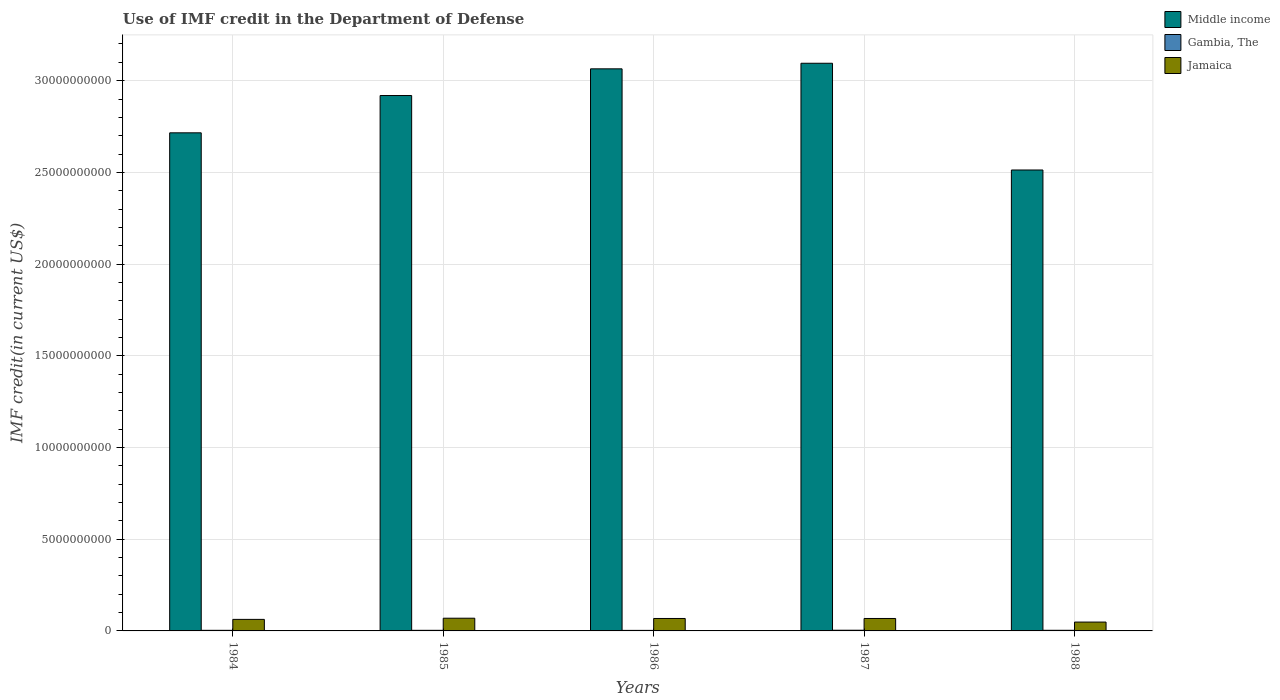How many different coloured bars are there?
Offer a very short reply. 3. How many groups of bars are there?
Provide a succinct answer. 5. How many bars are there on the 4th tick from the right?
Make the answer very short. 3. What is the label of the 4th group of bars from the left?
Provide a short and direct response. 1987. In how many cases, is the number of bars for a given year not equal to the number of legend labels?
Your answer should be very brief. 0. What is the IMF credit in the Department of Defense in Jamaica in 1984?
Your answer should be very brief. 6.29e+08. Across all years, what is the maximum IMF credit in the Department of Defense in Jamaica?
Your answer should be very brief. 6.93e+08. Across all years, what is the minimum IMF credit in the Department of Defense in Jamaica?
Your response must be concise. 4.83e+08. In which year was the IMF credit in the Department of Defense in Gambia, The maximum?
Offer a terse response. 1987. In which year was the IMF credit in the Department of Defense in Middle income minimum?
Give a very brief answer. 1988. What is the total IMF credit in the Department of Defense in Gambia, The in the graph?
Offer a very short reply. 1.68e+08. What is the difference between the IMF credit in the Department of Defense in Gambia, The in 1985 and that in 1986?
Give a very brief answer. 3.45e+06. What is the difference between the IMF credit in the Department of Defense in Gambia, The in 1988 and the IMF credit in the Department of Defense in Middle income in 1987?
Give a very brief answer. -3.09e+1. What is the average IMF credit in the Department of Defense in Jamaica per year?
Provide a succinct answer. 6.32e+08. In the year 1987, what is the difference between the IMF credit in the Department of Defense in Middle income and IMF credit in the Department of Defense in Jamaica?
Keep it short and to the point. 3.03e+1. What is the ratio of the IMF credit in the Department of Defense in Jamaica in 1985 to that in 1988?
Give a very brief answer. 1.44. What is the difference between the highest and the second highest IMF credit in the Department of Defense in Gambia, The?
Provide a succinct answer. 3.23e+06. What is the difference between the highest and the lowest IMF credit in the Department of Defense in Gambia, The?
Provide a succinct answer. 8.27e+06. What does the 1st bar from the left in 1987 represents?
Your answer should be compact. Middle income. What does the 1st bar from the right in 1987 represents?
Provide a succinct answer. Jamaica. Is it the case that in every year, the sum of the IMF credit in the Department of Defense in Gambia, The and IMF credit in the Department of Defense in Jamaica is greater than the IMF credit in the Department of Defense in Middle income?
Keep it short and to the point. No. Are all the bars in the graph horizontal?
Provide a succinct answer. No. How many years are there in the graph?
Provide a short and direct response. 5. Does the graph contain any zero values?
Your response must be concise. No. Where does the legend appear in the graph?
Provide a succinct answer. Top right. How are the legend labels stacked?
Your answer should be very brief. Vertical. What is the title of the graph?
Make the answer very short. Use of IMF credit in the Department of Defense. Does "Burkina Faso" appear as one of the legend labels in the graph?
Your answer should be compact. No. What is the label or title of the X-axis?
Ensure brevity in your answer.  Years. What is the label or title of the Y-axis?
Your answer should be compact. IMF credit(in current US$). What is the IMF credit(in current US$) in Middle income in 1984?
Keep it short and to the point. 2.72e+1. What is the IMF credit(in current US$) of Gambia, The in 1984?
Offer a terse response. 3.29e+07. What is the IMF credit(in current US$) of Jamaica in 1984?
Ensure brevity in your answer.  6.29e+08. What is the IMF credit(in current US$) of Middle income in 1985?
Offer a terse response. 2.92e+1. What is the IMF credit(in current US$) in Gambia, The in 1985?
Your answer should be very brief. 3.30e+07. What is the IMF credit(in current US$) of Jamaica in 1985?
Your response must be concise. 6.93e+08. What is the IMF credit(in current US$) in Middle income in 1986?
Provide a succinct answer. 3.06e+1. What is the IMF credit(in current US$) in Gambia, The in 1986?
Keep it short and to the point. 2.95e+07. What is the IMF credit(in current US$) in Jamaica in 1986?
Offer a terse response. 6.78e+08. What is the IMF credit(in current US$) in Middle income in 1987?
Your answer should be very brief. 3.09e+1. What is the IMF credit(in current US$) in Gambia, The in 1987?
Your answer should be compact. 3.78e+07. What is the IMF credit(in current US$) in Jamaica in 1987?
Offer a very short reply. 6.78e+08. What is the IMF credit(in current US$) of Middle income in 1988?
Ensure brevity in your answer.  2.51e+1. What is the IMF credit(in current US$) of Gambia, The in 1988?
Your answer should be compact. 3.46e+07. What is the IMF credit(in current US$) of Jamaica in 1988?
Ensure brevity in your answer.  4.83e+08. Across all years, what is the maximum IMF credit(in current US$) in Middle income?
Ensure brevity in your answer.  3.09e+1. Across all years, what is the maximum IMF credit(in current US$) in Gambia, The?
Give a very brief answer. 3.78e+07. Across all years, what is the maximum IMF credit(in current US$) of Jamaica?
Ensure brevity in your answer.  6.93e+08. Across all years, what is the minimum IMF credit(in current US$) of Middle income?
Ensure brevity in your answer.  2.51e+1. Across all years, what is the minimum IMF credit(in current US$) in Gambia, The?
Your answer should be very brief. 2.95e+07. Across all years, what is the minimum IMF credit(in current US$) of Jamaica?
Make the answer very short. 4.83e+08. What is the total IMF credit(in current US$) in Middle income in the graph?
Your answer should be very brief. 1.43e+11. What is the total IMF credit(in current US$) of Gambia, The in the graph?
Provide a short and direct response. 1.68e+08. What is the total IMF credit(in current US$) of Jamaica in the graph?
Your answer should be very brief. 3.16e+09. What is the difference between the IMF credit(in current US$) of Middle income in 1984 and that in 1985?
Your response must be concise. -2.03e+09. What is the difference between the IMF credit(in current US$) in Gambia, The in 1984 and that in 1985?
Make the answer very short. -3.20e+04. What is the difference between the IMF credit(in current US$) of Jamaica in 1984 and that in 1985?
Keep it short and to the point. -6.45e+07. What is the difference between the IMF credit(in current US$) in Middle income in 1984 and that in 1986?
Ensure brevity in your answer.  -3.49e+09. What is the difference between the IMF credit(in current US$) in Gambia, The in 1984 and that in 1986?
Make the answer very short. 3.42e+06. What is the difference between the IMF credit(in current US$) of Jamaica in 1984 and that in 1986?
Give a very brief answer. -4.94e+07. What is the difference between the IMF credit(in current US$) of Middle income in 1984 and that in 1987?
Make the answer very short. -3.79e+09. What is the difference between the IMF credit(in current US$) of Gambia, The in 1984 and that in 1987?
Provide a short and direct response. -4.86e+06. What is the difference between the IMF credit(in current US$) in Jamaica in 1984 and that in 1987?
Offer a terse response. -4.97e+07. What is the difference between the IMF credit(in current US$) of Middle income in 1984 and that in 1988?
Give a very brief answer. 2.03e+09. What is the difference between the IMF credit(in current US$) in Gambia, The in 1984 and that in 1988?
Make the answer very short. -1.63e+06. What is the difference between the IMF credit(in current US$) in Jamaica in 1984 and that in 1988?
Your answer should be compact. 1.46e+08. What is the difference between the IMF credit(in current US$) of Middle income in 1985 and that in 1986?
Give a very brief answer. -1.46e+09. What is the difference between the IMF credit(in current US$) of Gambia, The in 1985 and that in 1986?
Your answer should be very brief. 3.45e+06. What is the difference between the IMF credit(in current US$) of Jamaica in 1985 and that in 1986?
Your answer should be compact. 1.50e+07. What is the difference between the IMF credit(in current US$) in Middle income in 1985 and that in 1987?
Your answer should be compact. -1.76e+09. What is the difference between the IMF credit(in current US$) in Gambia, The in 1985 and that in 1987?
Your response must be concise. -4.83e+06. What is the difference between the IMF credit(in current US$) in Jamaica in 1985 and that in 1987?
Your answer should be compact. 1.48e+07. What is the difference between the IMF credit(in current US$) of Middle income in 1985 and that in 1988?
Your answer should be compact. 4.06e+09. What is the difference between the IMF credit(in current US$) in Gambia, The in 1985 and that in 1988?
Your response must be concise. -1.60e+06. What is the difference between the IMF credit(in current US$) in Jamaica in 1985 and that in 1988?
Make the answer very short. 2.10e+08. What is the difference between the IMF credit(in current US$) in Middle income in 1986 and that in 1987?
Your response must be concise. -3.04e+08. What is the difference between the IMF credit(in current US$) of Gambia, The in 1986 and that in 1987?
Provide a short and direct response. -8.27e+06. What is the difference between the IMF credit(in current US$) in Jamaica in 1986 and that in 1987?
Offer a very short reply. -2.93e+05. What is the difference between the IMF credit(in current US$) of Middle income in 1986 and that in 1988?
Make the answer very short. 5.52e+09. What is the difference between the IMF credit(in current US$) of Gambia, The in 1986 and that in 1988?
Your answer should be compact. -5.04e+06. What is the difference between the IMF credit(in current US$) in Jamaica in 1986 and that in 1988?
Your answer should be compact. 1.95e+08. What is the difference between the IMF credit(in current US$) in Middle income in 1987 and that in 1988?
Keep it short and to the point. 5.82e+09. What is the difference between the IMF credit(in current US$) of Gambia, The in 1987 and that in 1988?
Keep it short and to the point. 3.23e+06. What is the difference between the IMF credit(in current US$) of Jamaica in 1987 and that in 1988?
Provide a short and direct response. 1.96e+08. What is the difference between the IMF credit(in current US$) in Middle income in 1984 and the IMF credit(in current US$) in Gambia, The in 1985?
Your answer should be very brief. 2.71e+1. What is the difference between the IMF credit(in current US$) in Middle income in 1984 and the IMF credit(in current US$) in Jamaica in 1985?
Your response must be concise. 2.65e+1. What is the difference between the IMF credit(in current US$) of Gambia, The in 1984 and the IMF credit(in current US$) of Jamaica in 1985?
Provide a succinct answer. -6.60e+08. What is the difference between the IMF credit(in current US$) of Middle income in 1984 and the IMF credit(in current US$) of Gambia, The in 1986?
Your response must be concise. 2.71e+1. What is the difference between the IMF credit(in current US$) in Middle income in 1984 and the IMF credit(in current US$) in Jamaica in 1986?
Your response must be concise. 2.65e+1. What is the difference between the IMF credit(in current US$) of Gambia, The in 1984 and the IMF credit(in current US$) of Jamaica in 1986?
Ensure brevity in your answer.  -6.45e+08. What is the difference between the IMF credit(in current US$) in Middle income in 1984 and the IMF credit(in current US$) in Gambia, The in 1987?
Your answer should be compact. 2.71e+1. What is the difference between the IMF credit(in current US$) of Middle income in 1984 and the IMF credit(in current US$) of Jamaica in 1987?
Give a very brief answer. 2.65e+1. What is the difference between the IMF credit(in current US$) of Gambia, The in 1984 and the IMF credit(in current US$) of Jamaica in 1987?
Make the answer very short. -6.46e+08. What is the difference between the IMF credit(in current US$) of Middle income in 1984 and the IMF credit(in current US$) of Gambia, The in 1988?
Make the answer very short. 2.71e+1. What is the difference between the IMF credit(in current US$) in Middle income in 1984 and the IMF credit(in current US$) in Jamaica in 1988?
Offer a terse response. 2.67e+1. What is the difference between the IMF credit(in current US$) of Gambia, The in 1984 and the IMF credit(in current US$) of Jamaica in 1988?
Offer a terse response. -4.50e+08. What is the difference between the IMF credit(in current US$) in Middle income in 1985 and the IMF credit(in current US$) in Gambia, The in 1986?
Give a very brief answer. 2.92e+1. What is the difference between the IMF credit(in current US$) in Middle income in 1985 and the IMF credit(in current US$) in Jamaica in 1986?
Offer a terse response. 2.85e+1. What is the difference between the IMF credit(in current US$) of Gambia, The in 1985 and the IMF credit(in current US$) of Jamaica in 1986?
Provide a succinct answer. -6.45e+08. What is the difference between the IMF credit(in current US$) in Middle income in 1985 and the IMF credit(in current US$) in Gambia, The in 1987?
Keep it short and to the point. 2.92e+1. What is the difference between the IMF credit(in current US$) in Middle income in 1985 and the IMF credit(in current US$) in Jamaica in 1987?
Provide a short and direct response. 2.85e+1. What is the difference between the IMF credit(in current US$) of Gambia, The in 1985 and the IMF credit(in current US$) of Jamaica in 1987?
Make the answer very short. -6.45e+08. What is the difference between the IMF credit(in current US$) of Middle income in 1985 and the IMF credit(in current US$) of Gambia, The in 1988?
Provide a succinct answer. 2.92e+1. What is the difference between the IMF credit(in current US$) of Middle income in 1985 and the IMF credit(in current US$) of Jamaica in 1988?
Keep it short and to the point. 2.87e+1. What is the difference between the IMF credit(in current US$) of Gambia, The in 1985 and the IMF credit(in current US$) of Jamaica in 1988?
Provide a short and direct response. -4.50e+08. What is the difference between the IMF credit(in current US$) in Middle income in 1986 and the IMF credit(in current US$) in Gambia, The in 1987?
Offer a terse response. 3.06e+1. What is the difference between the IMF credit(in current US$) of Middle income in 1986 and the IMF credit(in current US$) of Jamaica in 1987?
Your answer should be compact. 3.00e+1. What is the difference between the IMF credit(in current US$) of Gambia, The in 1986 and the IMF credit(in current US$) of Jamaica in 1987?
Your answer should be very brief. -6.49e+08. What is the difference between the IMF credit(in current US$) in Middle income in 1986 and the IMF credit(in current US$) in Gambia, The in 1988?
Your answer should be very brief. 3.06e+1. What is the difference between the IMF credit(in current US$) of Middle income in 1986 and the IMF credit(in current US$) of Jamaica in 1988?
Ensure brevity in your answer.  3.02e+1. What is the difference between the IMF credit(in current US$) in Gambia, The in 1986 and the IMF credit(in current US$) in Jamaica in 1988?
Ensure brevity in your answer.  -4.53e+08. What is the difference between the IMF credit(in current US$) of Middle income in 1987 and the IMF credit(in current US$) of Gambia, The in 1988?
Keep it short and to the point. 3.09e+1. What is the difference between the IMF credit(in current US$) in Middle income in 1987 and the IMF credit(in current US$) in Jamaica in 1988?
Ensure brevity in your answer.  3.05e+1. What is the difference between the IMF credit(in current US$) of Gambia, The in 1987 and the IMF credit(in current US$) of Jamaica in 1988?
Offer a very short reply. -4.45e+08. What is the average IMF credit(in current US$) of Middle income per year?
Your answer should be very brief. 2.86e+1. What is the average IMF credit(in current US$) in Gambia, The per year?
Offer a very short reply. 3.36e+07. What is the average IMF credit(in current US$) in Jamaica per year?
Your answer should be compact. 6.32e+08. In the year 1984, what is the difference between the IMF credit(in current US$) of Middle income and IMF credit(in current US$) of Gambia, The?
Your response must be concise. 2.71e+1. In the year 1984, what is the difference between the IMF credit(in current US$) of Middle income and IMF credit(in current US$) of Jamaica?
Offer a terse response. 2.65e+1. In the year 1984, what is the difference between the IMF credit(in current US$) of Gambia, The and IMF credit(in current US$) of Jamaica?
Keep it short and to the point. -5.96e+08. In the year 1985, what is the difference between the IMF credit(in current US$) in Middle income and IMF credit(in current US$) in Gambia, The?
Provide a succinct answer. 2.92e+1. In the year 1985, what is the difference between the IMF credit(in current US$) in Middle income and IMF credit(in current US$) in Jamaica?
Provide a succinct answer. 2.85e+1. In the year 1985, what is the difference between the IMF credit(in current US$) in Gambia, The and IMF credit(in current US$) in Jamaica?
Keep it short and to the point. -6.60e+08. In the year 1986, what is the difference between the IMF credit(in current US$) in Middle income and IMF credit(in current US$) in Gambia, The?
Make the answer very short. 3.06e+1. In the year 1986, what is the difference between the IMF credit(in current US$) in Middle income and IMF credit(in current US$) in Jamaica?
Offer a very short reply. 3.00e+1. In the year 1986, what is the difference between the IMF credit(in current US$) in Gambia, The and IMF credit(in current US$) in Jamaica?
Your answer should be very brief. -6.49e+08. In the year 1987, what is the difference between the IMF credit(in current US$) of Middle income and IMF credit(in current US$) of Gambia, The?
Your answer should be very brief. 3.09e+1. In the year 1987, what is the difference between the IMF credit(in current US$) in Middle income and IMF credit(in current US$) in Jamaica?
Keep it short and to the point. 3.03e+1. In the year 1987, what is the difference between the IMF credit(in current US$) in Gambia, The and IMF credit(in current US$) in Jamaica?
Make the answer very short. -6.41e+08. In the year 1988, what is the difference between the IMF credit(in current US$) of Middle income and IMF credit(in current US$) of Gambia, The?
Your answer should be compact. 2.51e+1. In the year 1988, what is the difference between the IMF credit(in current US$) of Middle income and IMF credit(in current US$) of Jamaica?
Offer a terse response. 2.46e+1. In the year 1988, what is the difference between the IMF credit(in current US$) in Gambia, The and IMF credit(in current US$) in Jamaica?
Your answer should be very brief. -4.48e+08. What is the ratio of the IMF credit(in current US$) of Middle income in 1984 to that in 1985?
Offer a terse response. 0.93. What is the ratio of the IMF credit(in current US$) in Jamaica in 1984 to that in 1985?
Ensure brevity in your answer.  0.91. What is the ratio of the IMF credit(in current US$) in Middle income in 1984 to that in 1986?
Your answer should be very brief. 0.89. What is the ratio of the IMF credit(in current US$) in Gambia, The in 1984 to that in 1986?
Give a very brief answer. 1.12. What is the ratio of the IMF credit(in current US$) of Jamaica in 1984 to that in 1986?
Provide a succinct answer. 0.93. What is the ratio of the IMF credit(in current US$) in Middle income in 1984 to that in 1987?
Your response must be concise. 0.88. What is the ratio of the IMF credit(in current US$) in Gambia, The in 1984 to that in 1987?
Make the answer very short. 0.87. What is the ratio of the IMF credit(in current US$) of Jamaica in 1984 to that in 1987?
Give a very brief answer. 0.93. What is the ratio of the IMF credit(in current US$) in Middle income in 1984 to that in 1988?
Your response must be concise. 1.08. What is the ratio of the IMF credit(in current US$) in Gambia, The in 1984 to that in 1988?
Provide a succinct answer. 0.95. What is the ratio of the IMF credit(in current US$) in Jamaica in 1984 to that in 1988?
Provide a succinct answer. 1.3. What is the ratio of the IMF credit(in current US$) in Middle income in 1985 to that in 1986?
Give a very brief answer. 0.95. What is the ratio of the IMF credit(in current US$) of Gambia, The in 1985 to that in 1986?
Offer a terse response. 1.12. What is the ratio of the IMF credit(in current US$) in Jamaica in 1985 to that in 1986?
Your response must be concise. 1.02. What is the ratio of the IMF credit(in current US$) in Middle income in 1985 to that in 1987?
Provide a short and direct response. 0.94. What is the ratio of the IMF credit(in current US$) of Gambia, The in 1985 to that in 1987?
Give a very brief answer. 0.87. What is the ratio of the IMF credit(in current US$) in Jamaica in 1985 to that in 1987?
Provide a succinct answer. 1.02. What is the ratio of the IMF credit(in current US$) in Middle income in 1985 to that in 1988?
Make the answer very short. 1.16. What is the ratio of the IMF credit(in current US$) in Gambia, The in 1985 to that in 1988?
Offer a very short reply. 0.95. What is the ratio of the IMF credit(in current US$) in Jamaica in 1985 to that in 1988?
Offer a very short reply. 1.44. What is the ratio of the IMF credit(in current US$) in Middle income in 1986 to that in 1987?
Keep it short and to the point. 0.99. What is the ratio of the IMF credit(in current US$) in Gambia, The in 1986 to that in 1987?
Your answer should be compact. 0.78. What is the ratio of the IMF credit(in current US$) in Middle income in 1986 to that in 1988?
Your answer should be very brief. 1.22. What is the ratio of the IMF credit(in current US$) in Gambia, The in 1986 to that in 1988?
Keep it short and to the point. 0.85. What is the ratio of the IMF credit(in current US$) in Jamaica in 1986 to that in 1988?
Your answer should be compact. 1.4. What is the ratio of the IMF credit(in current US$) of Middle income in 1987 to that in 1988?
Your answer should be very brief. 1.23. What is the ratio of the IMF credit(in current US$) in Gambia, The in 1987 to that in 1988?
Offer a very short reply. 1.09. What is the ratio of the IMF credit(in current US$) of Jamaica in 1987 to that in 1988?
Your response must be concise. 1.41. What is the difference between the highest and the second highest IMF credit(in current US$) of Middle income?
Give a very brief answer. 3.04e+08. What is the difference between the highest and the second highest IMF credit(in current US$) of Gambia, The?
Your answer should be very brief. 3.23e+06. What is the difference between the highest and the second highest IMF credit(in current US$) of Jamaica?
Offer a very short reply. 1.48e+07. What is the difference between the highest and the lowest IMF credit(in current US$) in Middle income?
Your answer should be compact. 5.82e+09. What is the difference between the highest and the lowest IMF credit(in current US$) in Gambia, The?
Provide a succinct answer. 8.27e+06. What is the difference between the highest and the lowest IMF credit(in current US$) in Jamaica?
Provide a succinct answer. 2.10e+08. 